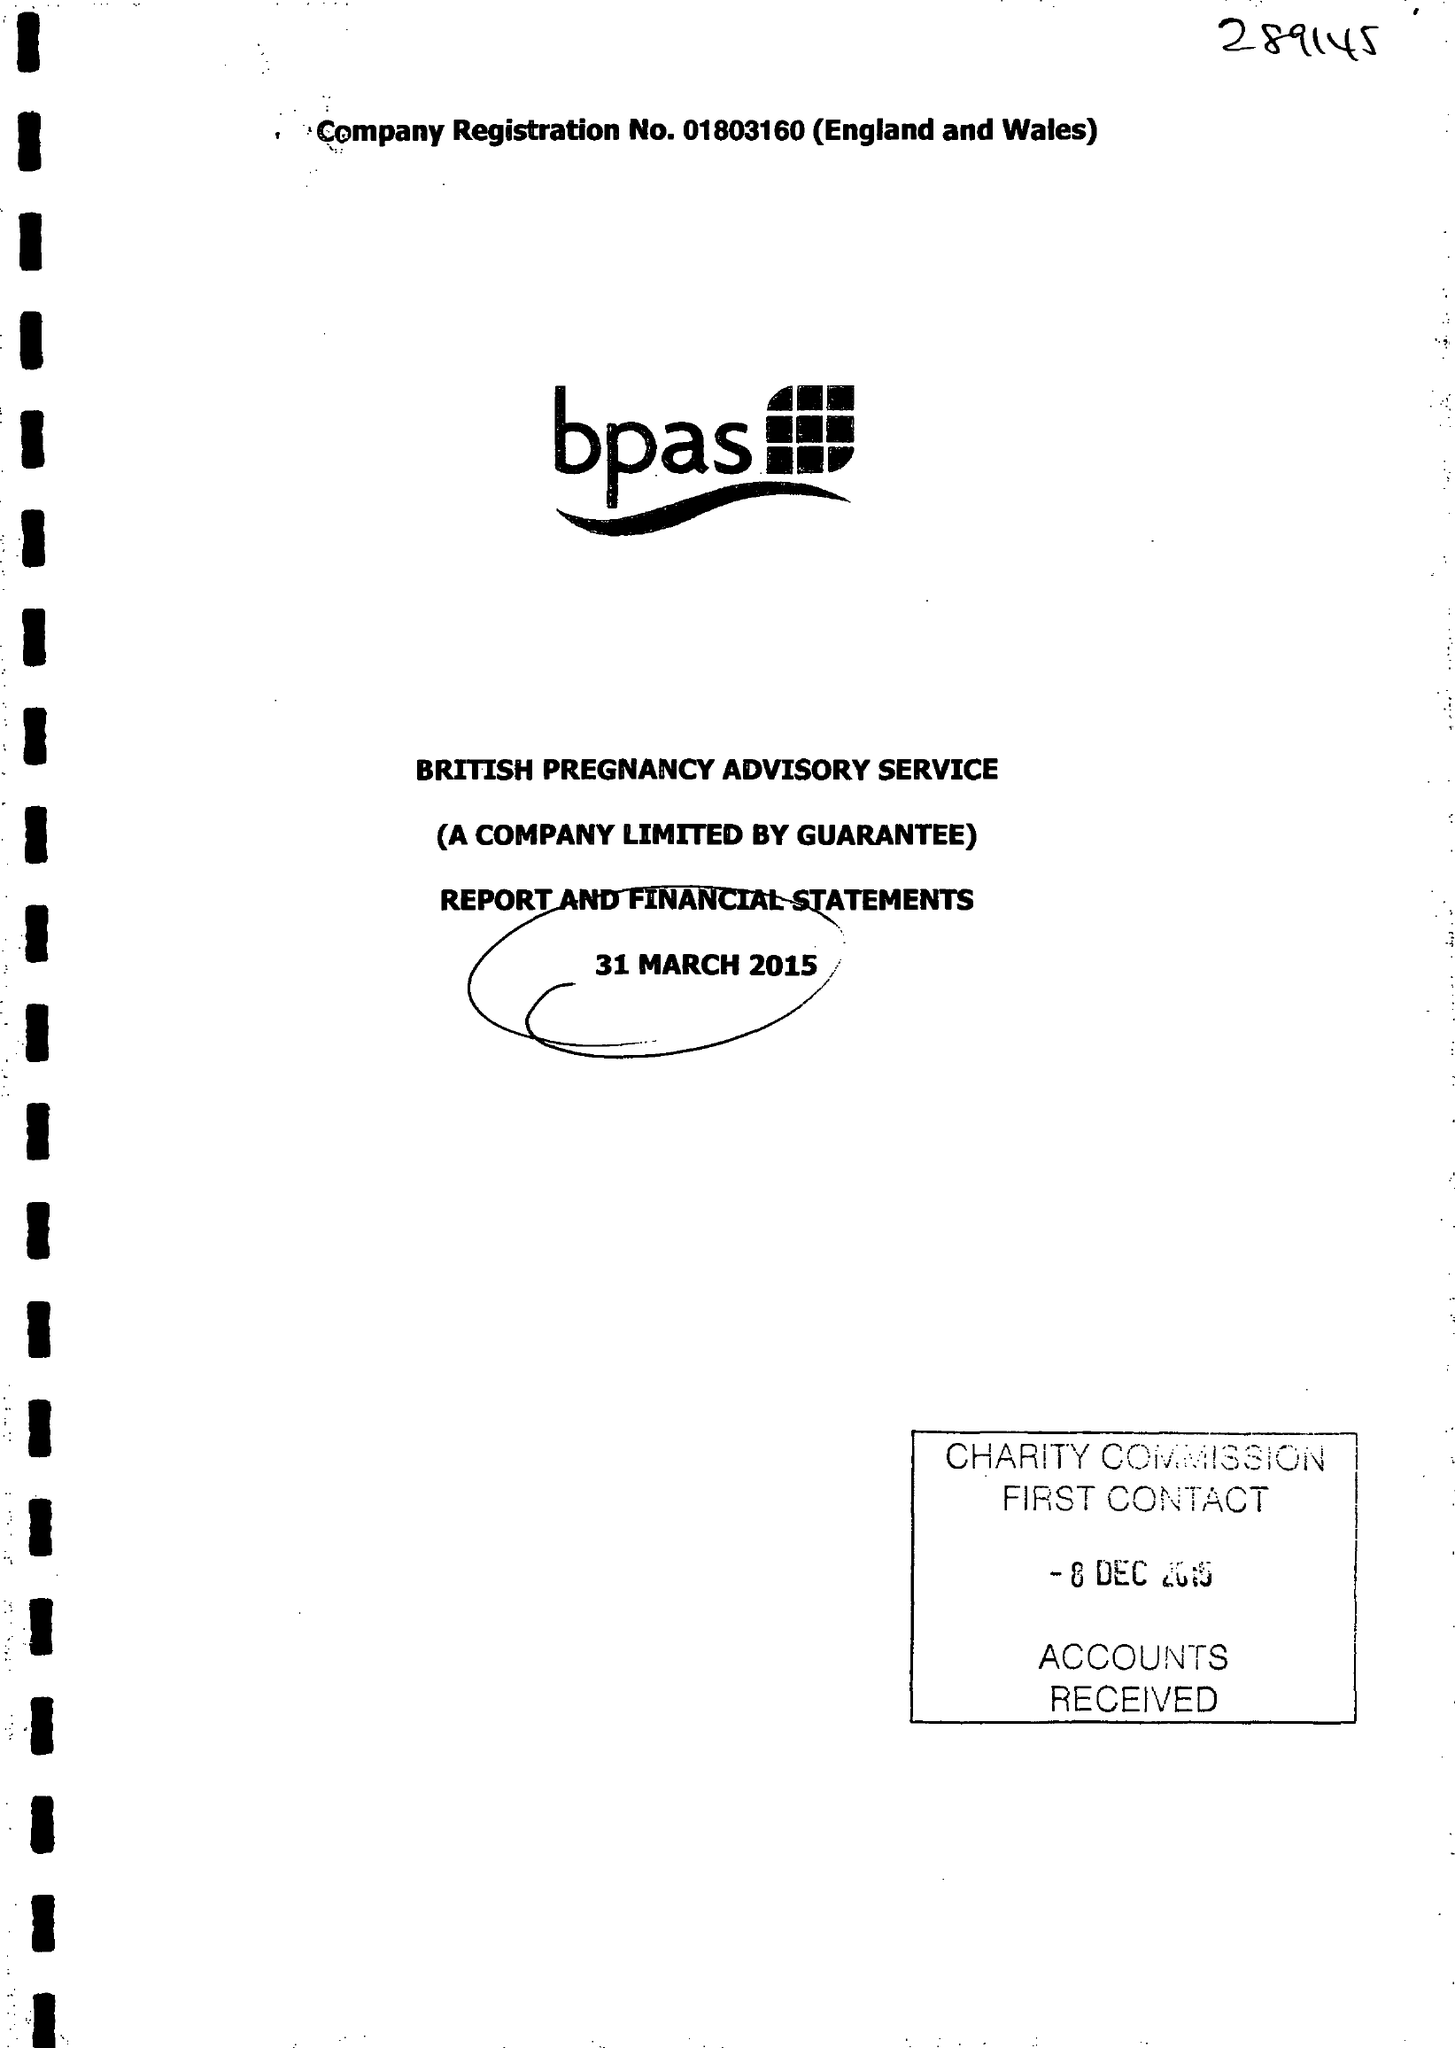What is the value for the report_date?
Answer the question using a single word or phrase. 2015-03-31 